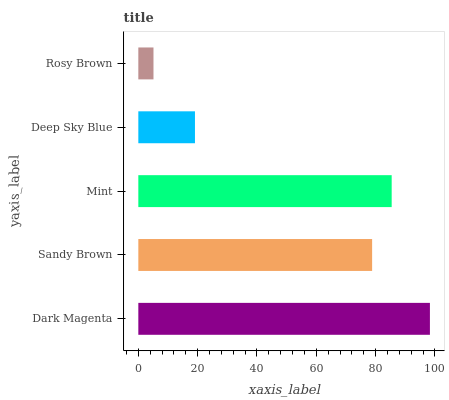Is Rosy Brown the minimum?
Answer yes or no. Yes. Is Dark Magenta the maximum?
Answer yes or no. Yes. Is Sandy Brown the minimum?
Answer yes or no. No. Is Sandy Brown the maximum?
Answer yes or no. No. Is Dark Magenta greater than Sandy Brown?
Answer yes or no. Yes. Is Sandy Brown less than Dark Magenta?
Answer yes or no. Yes. Is Sandy Brown greater than Dark Magenta?
Answer yes or no. No. Is Dark Magenta less than Sandy Brown?
Answer yes or no. No. Is Sandy Brown the high median?
Answer yes or no. Yes. Is Sandy Brown the low median?
Answer yes or no. Yes. Is Rosy Brown the high median?
Answer yes or no. No. Is Rosy Brown the low median?
Answer yes or no. No. 